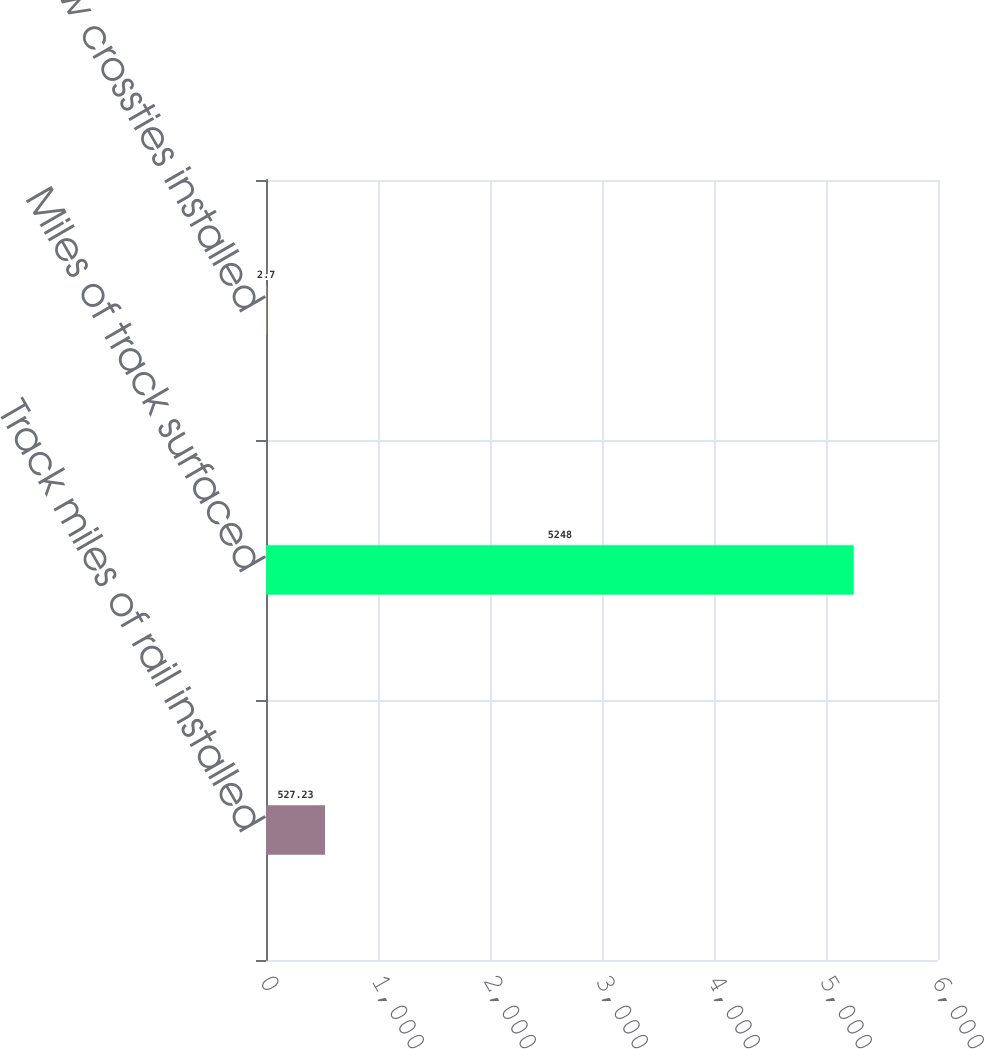Convert chart to OTSL. <chart><loc_0><loc_0><loc_500><loc_500><bar_chart><fcel>Track miles of rail installed<fcel>Miles of track surfaced<fcel>New crossties installed<nl><fcel>527.23<fcel>5248<fcel>2.7<nl></chart> 